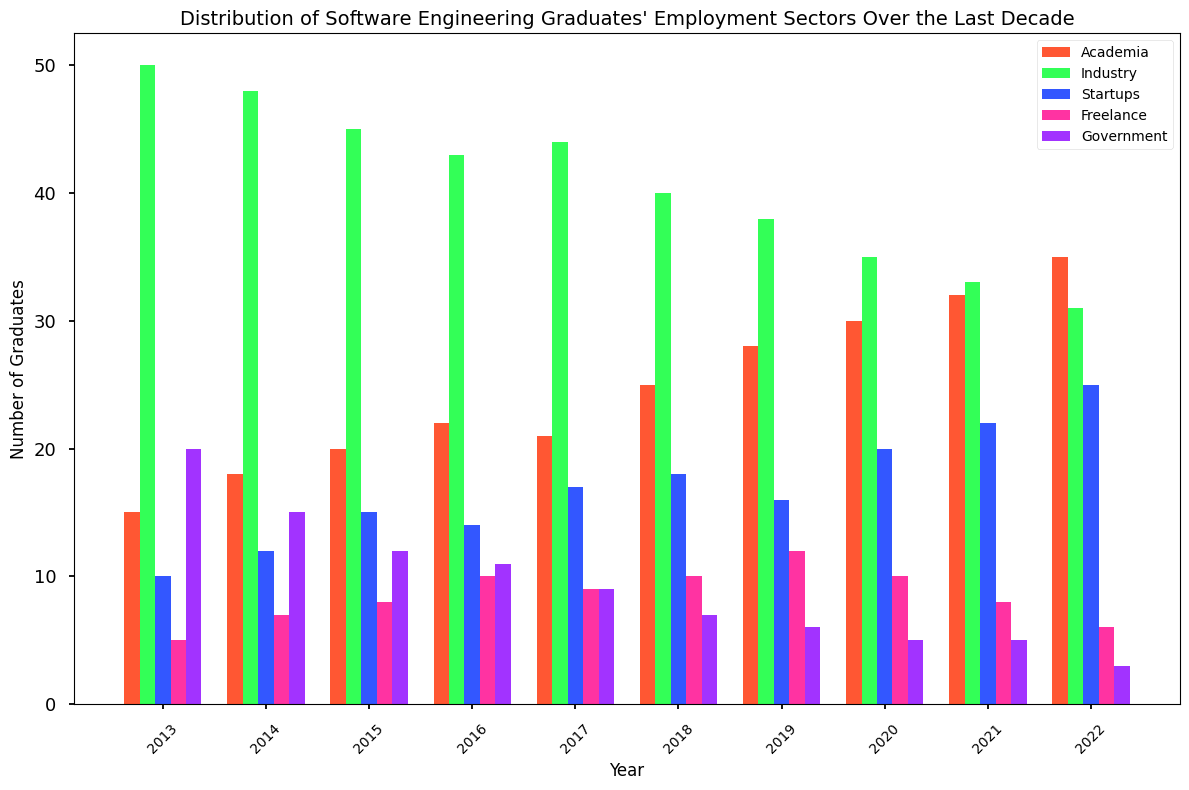What is the overall trend in the number of graduates employed in academia over the last decade? Look at the heights of the bars representing academia for each year from 2013 to 2022. Observe if the bars are increasing, decreasing, or remaining constant.
Answer: Increasing In which year did the industry have the lowest number of graduates employed? Identify the shortest bar for the industry (green bars) among all the years.
Answer: 2022 How many graduates were employed in startups and government sectors combined in 2017? Find the bar height for the startups and government in 2017 and add them together. Startups: 17, Government: 9, Total: 17 + 9 = 26.
Answer: 26 Which employment sector saw the most significant increase in number of graduates from 2013 to 2022? Compare the difference in the height of bars for each sector between 2013 and 2022. Calculate the increase: Academia: 35 - 15 = 20, Industry: 50 - 31 = 19, Startups: 25 - 10 = 15, Freelance: 6 - 5 = 1, Government: 20 - 3 = 17. The sector with the highest increase is Academia.
Answer: Academia What is the difference in the number of graduates employed in industry between 2015 and 2019? Subtract the height of the industry bar in 2019 from that in 2015. 2015: 45, 2019: 38, Difference: 45 - 38 = 7.
Answer: 7 Which year had the smallest difference between the number of graduates in academia and industry? Calculate the absolute difference between the heights of the bars for academia and industry for each year, then find the smallest difference.
Answer: 2016 In 2020, which sector had more graduates employed: freelance or government? Compare the heights of the bars for freelance and government in 2020. Freelance: 10, Government: 5. Freelance is higher.
Answer: Freelance 